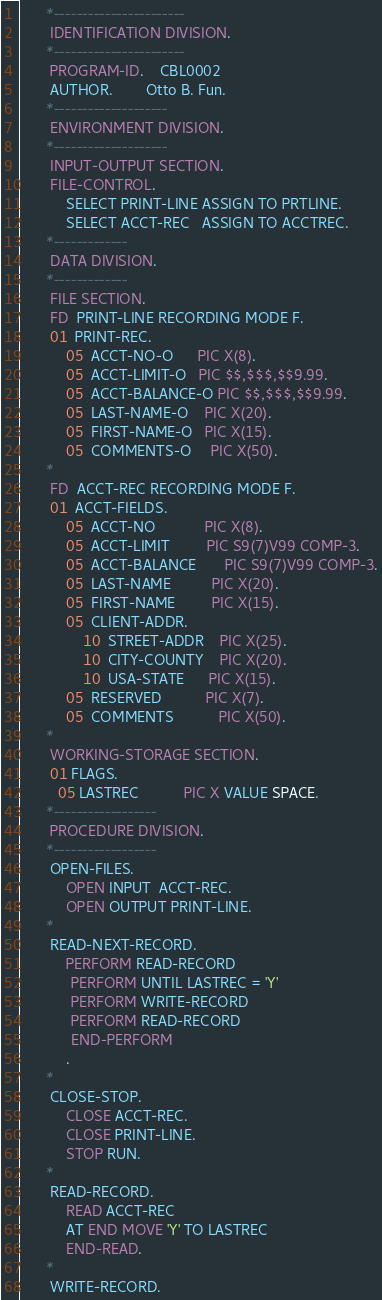<code> <loc_0><loc_0><loc_500><loc_500><_COBOL_>      *-----------------------
       IDENTIFICATION DIVISION.
      *-----------------------
       PROGRAM-ID.    CBL0002
       AUTHOR.        Otto B. Fun.
      *--------------------
       ENVIRONMENT DIVISION.
      *--------------------
       INPUT-OUTPUT SECTION.
       FILE-CONTROL.
           SELECT PRINT-LINE ASSIGN TO PRTLINE.
           SELECT ACCT-REC   ASSIGN TO ACCTREC.
      *-------------
       DATA DIVISION.
      *-------------
       FILE SECTION.
       FD  PRINT-LINE RECORDING MODE F.
       01  PRINT-REC.
           05  ACCT-NO-O      PIC X(8).
           05  ACCT-LIMIT-O   PIC $$,$$$,$$9.99.
           05  ACCT-BALANCE-O PIC $$,$$$,$$9.99.
           05  LAST-NAME-O    PIC X(20).
           05  FIRST-NAME-O   PIC X(15).
           05  COMMENTS-O     PIC X(50).
      *
       FD  ACCT-REC RECORDING MODE F.
       01  ACCT-FIELDS.
           05  ACCT-NO            PIC X(8).
           05  ACCT-LIMIT         PIC S9(7)V99 COMP-3.
           05  ACCT-BALANCE       PIC S9(7)V99 COMP-3.
           05  LAST-NAME          PIC X(20).
           05  FIRST-NAME         PIC X(15).
           05  CLIENT-ADDR.
               10  STREET-ADDR    PIC X(25).
               10  CITY-COUNTY    PIC X(20).
               10  USA-STATE      PIC X(15).
           05  RESERVED           PIC X(7).
           05  COMMENTS           PIC X(50).
      *
       WORKING-STORAGE SECTION.
       01 FLAGS.
         05 LASTREC           PIC X VALUE SPACE.
      *------------------
       PROCEDURE DIVISION.
      *------------------
       OPEN-FILES.
           OPEN INPUT  ACCT-REC.
           OPEN OUTPUT PRINT-LINE.
      *
       READ-NEXT-RECORD.
           PERFORM READ-RECORD
            PERFORM UNTIL LASTREC = 'Y'
            PERFORM WRITE-RECORD
            PERFORM READ-RECORD
            END-PERFORM
           .
      *
       CLOSE-STOP.
           CLOSE ACCT-REC.
           CLOSE PRINT-LINE.
           STOP RUN.
      *
       READ-RECORD.
           READ ACCT-REC
           AT END MOVE 'Y' TO LASTREC
           END-READ.
      *
       WRITE-RECORD.</code> 